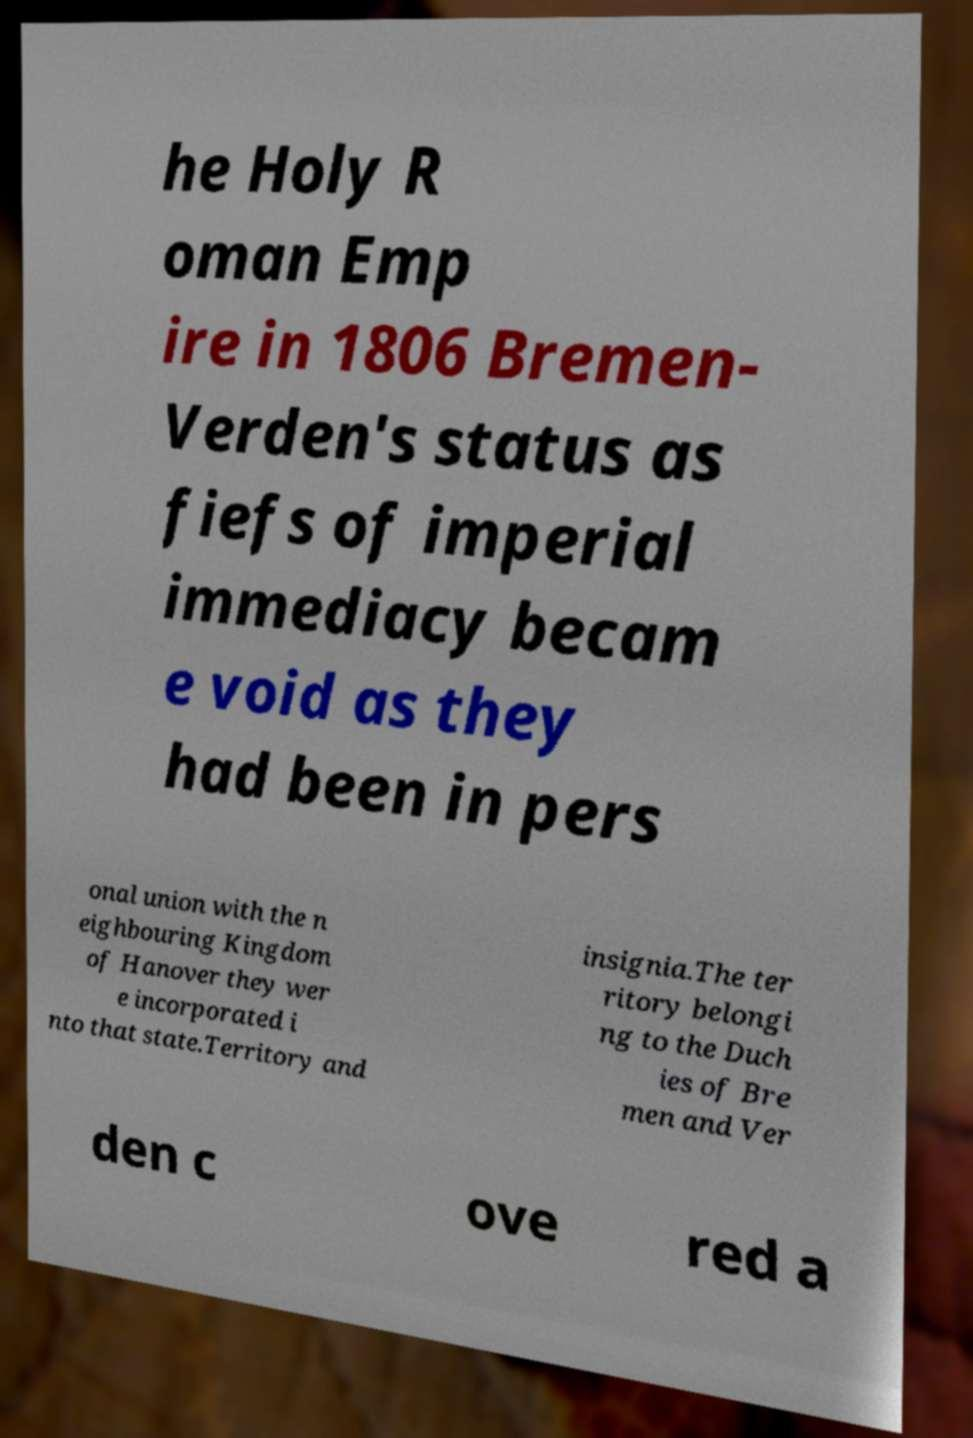Can you read and provide the text displayed in the image?This photo seems to have some interesting text. Can you extract and type it out for me? he Holy R oman Emp ire in 1806 Bremen- Verden's status as fiefs of imperial immediacy becam e void as they had been in pers onal union with the n eighbouring Kingdom of Hanover they wer e incorporated i nto that state.Territory and insignia.The ter ritory belongi ng to the Duch ies of Bre men and Ver den c ove red a 